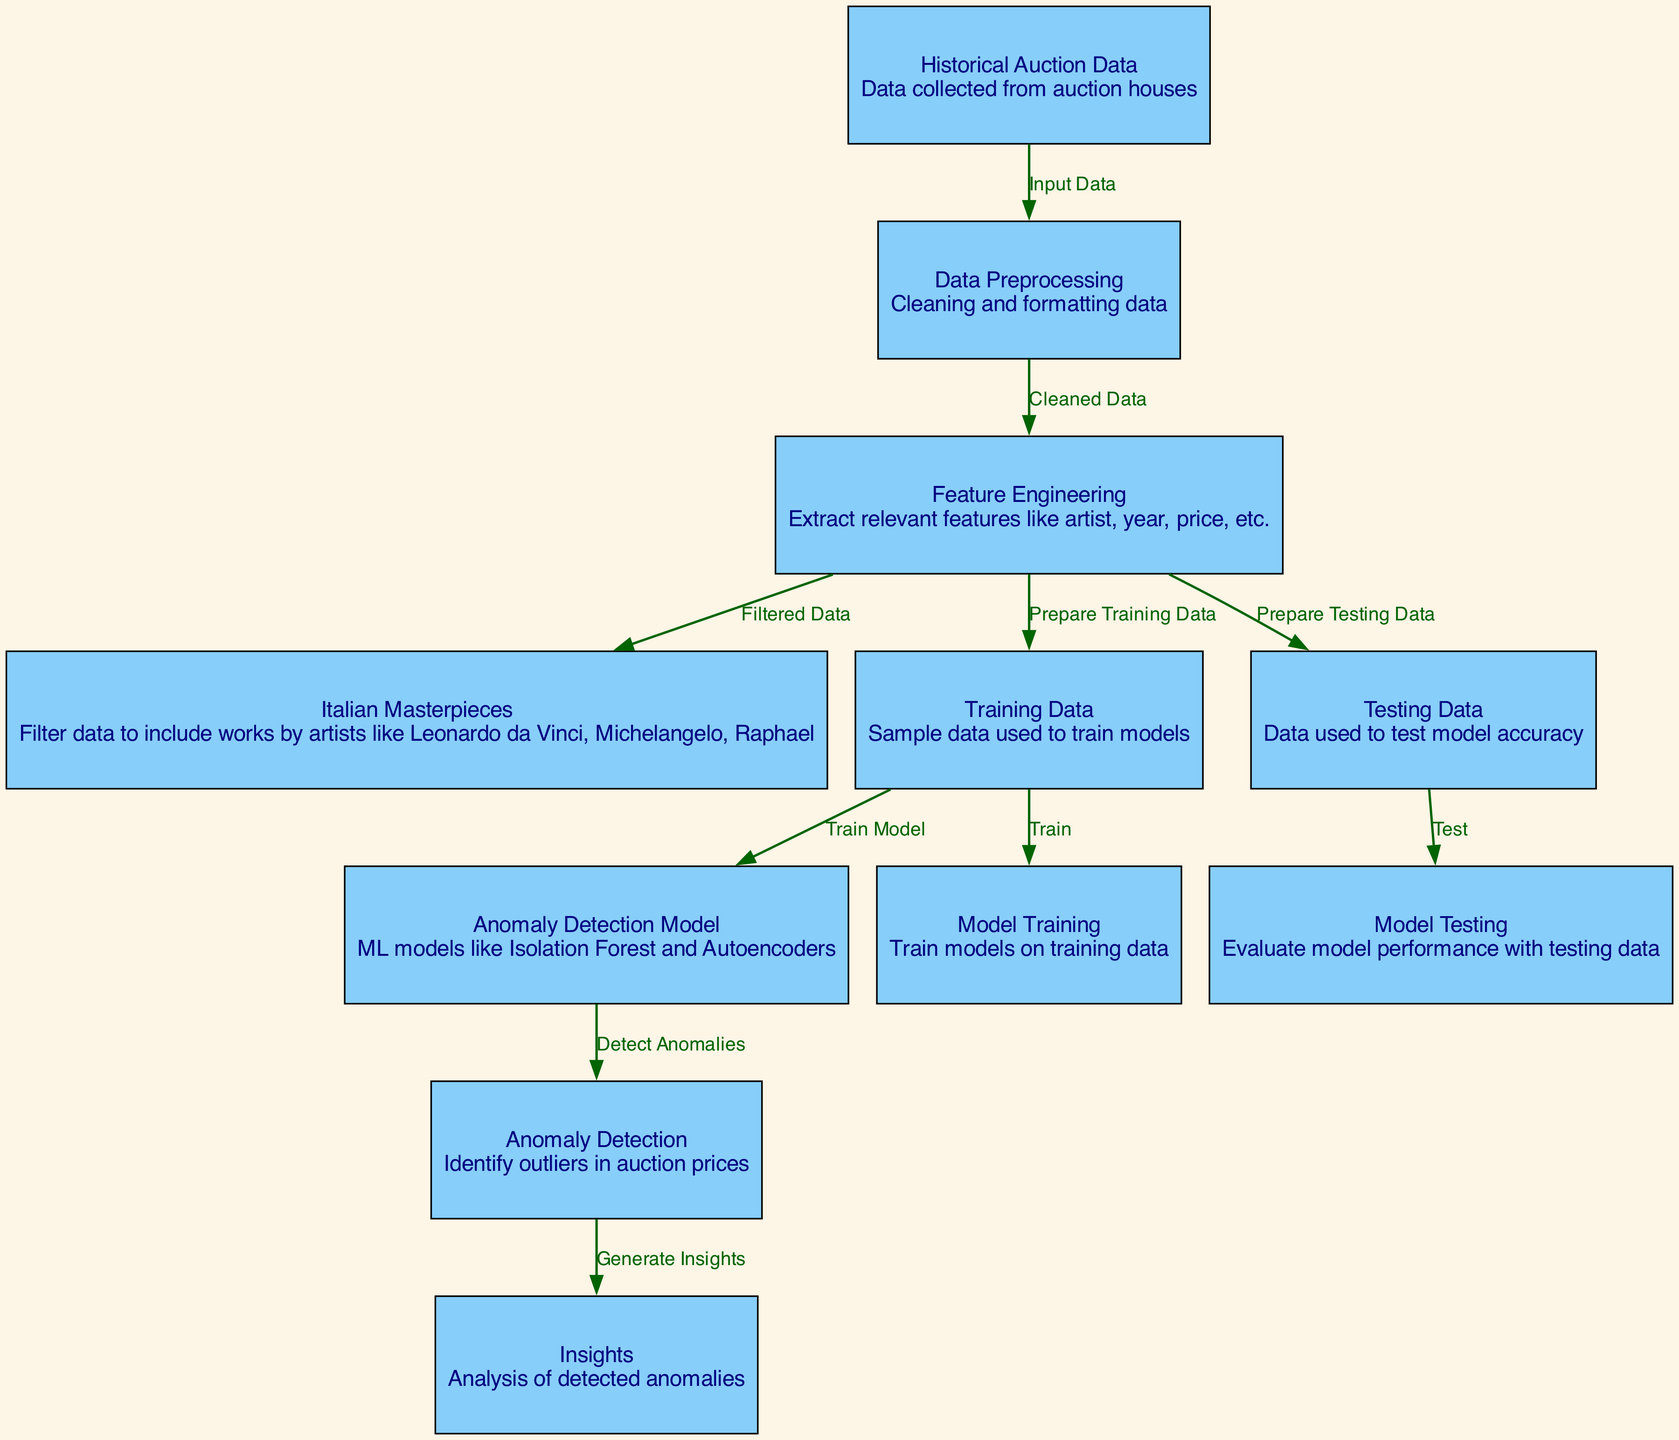What is the starting point for the diagram? The starting point, or the first node in the diagram, is the "Historical Auction Data," which serves as the input data collected from auction houses for the entire anomaly detection process.
Answer: Historical Auction Data How many nodes are in the diagram? By counting all the unique nodes listed in the diagram, we can see that there are a total of eleven nodes representing different stages of the anomaly detection process.
Answer: Eleven Which node is responsible for filtering data specific to Italian artists? The node titled "Italian Masterpieces" is responsible for filtering the data to include works specifically by renowned Italian artists like Leonardo da Vinci, Michelangelo, and Raphael.
Answer: Italian Masterpieces What flows from "Training Data" to "Anomaly Detection Model"? The relationship indicates that the training data is utilized to train various models, such as Isolation Forest and Autoencoders, which are then used for detecting anomalies in auction prices.
Answer: Train Model What is the final output of the diagram? The final output of the diagram is generated insights following the process of anomaly detection, summarizing the analysis of the anomalies detected in art auction prices.
Answer: Insights How does the data transition from "Data Preprocessing" to "Feature Engineering"? The transition from "Data Preprocessing" to "Feature Engineering" indicates that after the data is cleaned and formatted, the next step is to extract relevant features for further analysis, completing the preprocessing stage.
Answer: Extract relevant features Which models are listed as part of the anomaly detection method? The models mentioned in the diagram include Isolation Forest and Autoencoders, both of which are used in the process for identifying outliers in auction prices.
Answer: Isolation Forest and Autoencoders What does the edge labeled "Prepare Testing Data" connect? The edge labeled "Prepare Testing Data" connects the "Feature Engineering" node to the "Testing Data" node, indicating that processed features are used to prepare the data for testing model accuracy.
Answer: Testing Data What is the purpose of the "Anomaly Detection" node? The "Anomaly Detection" node serves the purpose of identifying outliers in auction prices after the model has been trained on the training data.
Answer: Identify outliers 